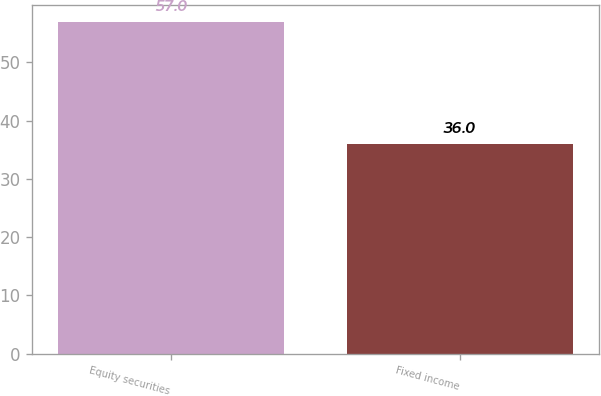Convert chart. <chart><loc_0><loc_0><loc_500><loc_500><bar_chart><fcel>Equity securities<fcel>Fixed income<nl><fcel>57<fcel>36<nl></chart> 